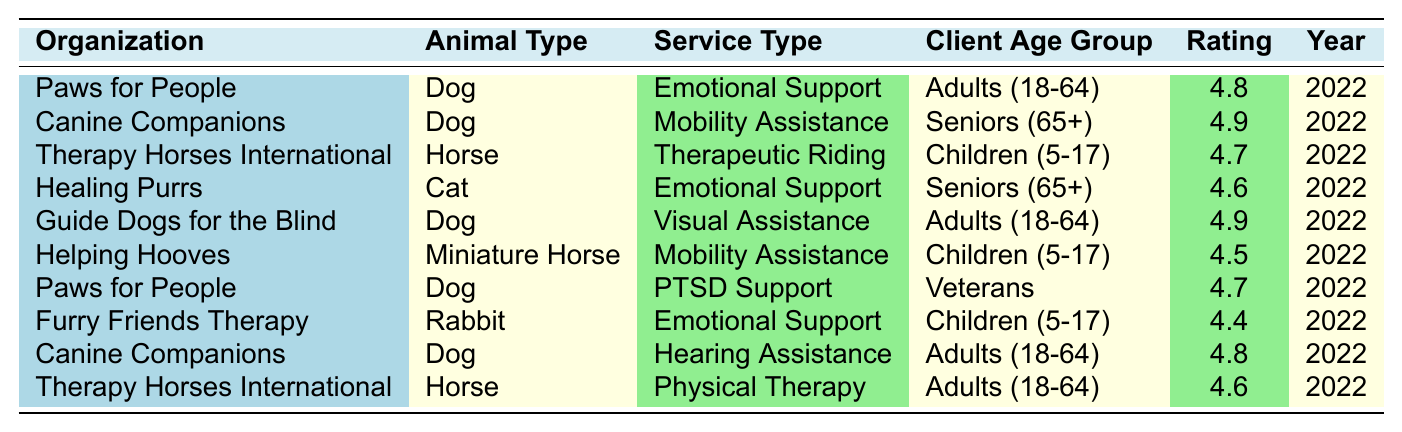What is the highest satisfaction rating among the specified services? Scanning the table, the highest satisfaction rating listed is 4.9 for both "Canine Companions" (Mobility Assistance for Seniors) and "Guide Dogs for the Blind" (Visual Assistance for Adults).
Answer: 4.9 Which organization provides emotional support for adults aged 18-64? Looking through the table, "Paws for People" offers emotional support for adults aged 18-64 with a satisfaction rating of 4.8.
Answer: Paws for People How many support animal services have a satisfaction rating of 4.6? Examining each entry, it shows that there are three services with a satisfaction rating of 4.6: Healing Purrs (Emotional Support for Seniors), Therapy Horses International (Physical Therapy for Adults), and one more which is Therapy Horses International (Therapeutic Riding for Children).
Answer: 3 What is the average satisfaction rating for services aimed at children aged 5-17? The satisfaction ratings for children aged 5-17 are 4.7 (Therapeutic Riding), 4.5 (Mobility Assistance), and 4.4 (Emotional Support). The average is calculated by summing these ratings: (4.7 + 4.5 + 4.4) = 13.6, and dividing by the number of services: 13.6/3 = 4.53.
Answer: 4.53 Is it true that "Helping Hooves" received a satisfaction rating of 4.5? Checking the table confirms that "Helping Hooves" indeed has a satisfaction rating of 4.5 for their Mobility Assistance service.
Answer: Yes Which age group has the highest average satisfaction rating based on the table? The satisfaction ratings for each age group are calculated: Adults (18-64) have ratings of 4.8, 4.9, and 4.8 (average = 4.85), Seniors (65+) have ratings of 4.9 and 4.6 (average = 4.75), Children (5-17) have ratings of 4.7, 4.5, and 4.4 (average = 4.53), and Veterans have a rating of 4.7. Adults (18-64) have the highest average.
Answer: Adults (18-64) What service type received the lowest satisfaction rating? The lowest satisfaction rating is found under the "Furry Friends Therapy" (Emotional Support for Children) with a rating of 4.4.
Answer: Emotional Support Do any organizations provide services to veterans? Yes, "Paws for People" provides PTSD Support services specifically for veterans.
Answer: Yes How many organizations rated 4.7 for their services? Reviewing the table indicates that there are three organizations with a rating of 4.7: "Therapy Horses International" (Therapeutic Riding for Children), "Paws for People" (PTSD Support for Veterans), and "Canine Companions" (Mobility Assistance for Seniors).
Answer: 3 Which service provides the best client satisfaction based on the data? The "Canine Companions" (Mobility Assistance for Seniors) and "Guide Dogs for the Blind" (Visual Assistance for Adults) both have the top rating of 4.9, indicating they provide the best client satisfaction.
Answer: 4.9 